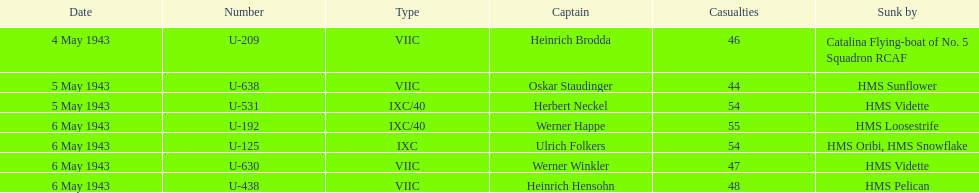What was the number of casualties on may 4 1943? 46. 